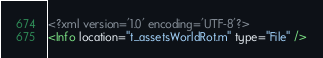<code> <loc_0><loc_0><loc_500><loc_500><_XML_><?xml version='1.0' encoding='UTF-8'?>
<Info location="t_assetsWorldRot.m" type="File" /></code> 